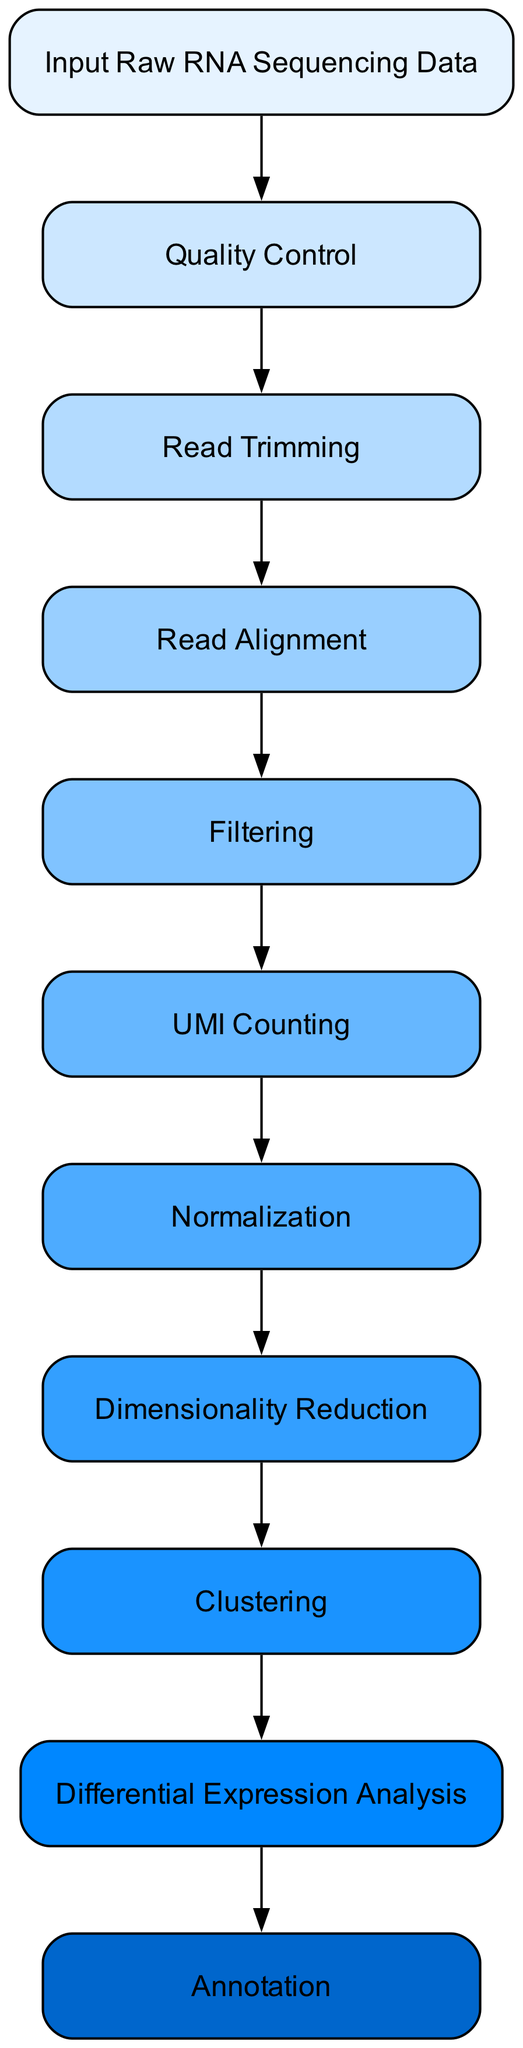What is the first step in the data processing pipeline? The first node in the flowchart is labeled "Input Raw RNA Sequencing Data," indicating that it is the starting point of the pipeline where initial data is provided for processing.
Answer: Input Raw RNA Sequencing Data How many nodes are there in the flowchart? Counting each step in the flowchart from the input to the final annotation gives a total of 11 distinct nodes.
Answer: 11 What process follows Read Trimming? After the "Read Trimming" node, the next step in the flowchart is "Read Alignment," which indicates what happens after the reads are trimmed.
Answer: Read Alignment What type of analysis is performed after Clustering? Following the "Clustering" step, the next analytical step indicated in the flowchart is "Differential Expression Analysis," which focuses on comparing gene expression levels across different clusters.
Answer: Differential Expression Analysis Which tool is suggested for Quality Control? The description for the "Quality Control" step mentions using "FastQC" as a tool to assess the quality of the raw sequencing data.
Answer: FastQC How are cells filtered in this pipeline? The "Filtering" step involves filtering out cells and genes with low expression or poor quality, utilizing tools such as "Seurat" or "Scrublet" for identifying doublets.
Answer: Seurat or Scrublet What step comes after UMI Counting? After "UMI Counting," the next step in the data processing pipeline is "Normalization," where gene expression counts are adjusted for technical variations.
Answer: Normalization In which step would you identify marker genes? The "Annotation" step is where cell types and states are identified based on known marker genes and reference datasets, making it crucial for understanding cell identities.
Answer: Annotation What type of graph does this flowchart represent? This flowchart represents a directed graph that outlines the sequential steps involved in a data processing pipeline for single-cell RNA sequencing, illustrating the order and relationships among various processes.
Answer: Directed graph 